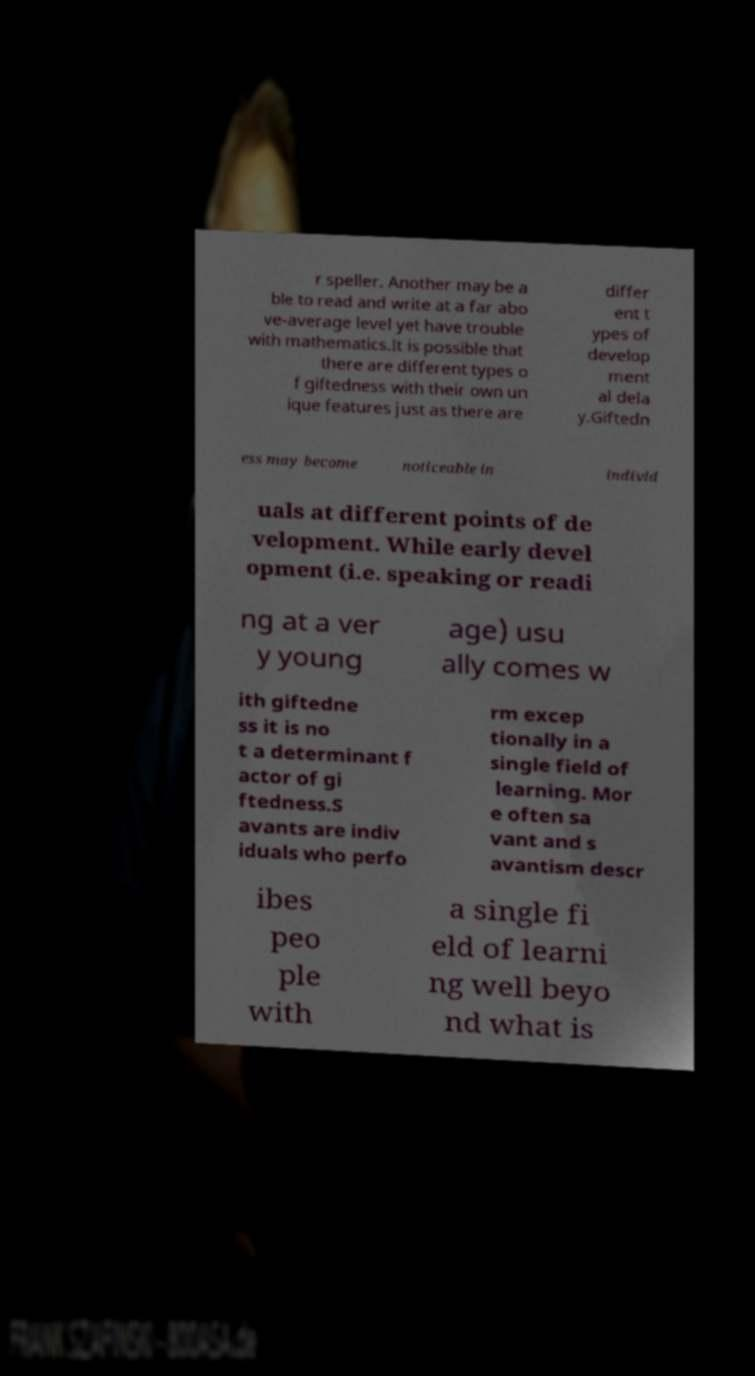I need the written content from this picture converted into text. Can you do that? r speller. Another may be a ble to read and write at a far abo ve-average level yet have trouble with mathematics.It is possible that there are different types o f giftedness with their own un ique features just as there are differ ent t ypes of develop ment al dela y.Giftedn ess may become noticeable in individ uals at different points of de velopment. While early devel opment (i.e. speaking or readi ng at a ver y young age) usu ally comes w ith giftedne ss it is no t a determinant f actor of gi ftedness.S avants are indiv iduals who perfo rm excep tionally in a single field of learning. Mor e often sa vant and s avantism descr ibes peo ple with a single fi eld of learni ng well beyo nd what is 